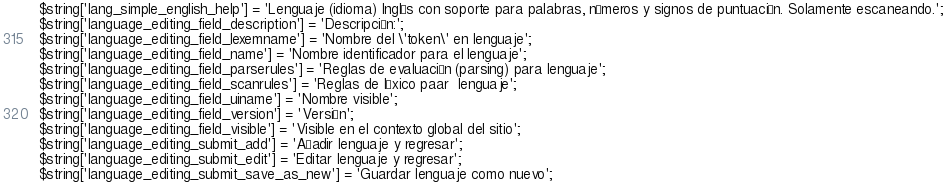<code> <loc_0><loc_0><loc_500><loc_500><_PHP_>$string['lang_simple_english_help'] = 'Lenguaje (idioma) Inglés con soporte para palabras, números y signos de puntuación. Solamente escaneando.';
$string['language_editing_field_description'] = 'Descripción:';
$string['language_editing_field_lexemname'] = 'Nombre del \'token\' en lenguaje';
$string['language_editing_field_name'] = 'Nombre identificador para el lenguaje';
$string['language_editing_field_parserules'] = 'Reglas de evaluación (parsing) para lenguaje';
$string['language_editing_field_scanrules'] = 'Reglas de léxico paar  lenguaje';
$string['language_editing_field_uiname'] = 'Nombre visible';
$string['language_editing_field_version'] = 'Versión';
$string['language_editing_field_visible'] = 'Visible en el contexto global del sitio';
$string['language_editing_submit_add'] = 'Añadir lenguaje y regresar';
$string['language_editing_submit_edit'] = 'Editar lenguaje y regresar';
$string['language_editing_submit_save_as_new'] = 'Guardar lenguaje como nuevo';</code> 